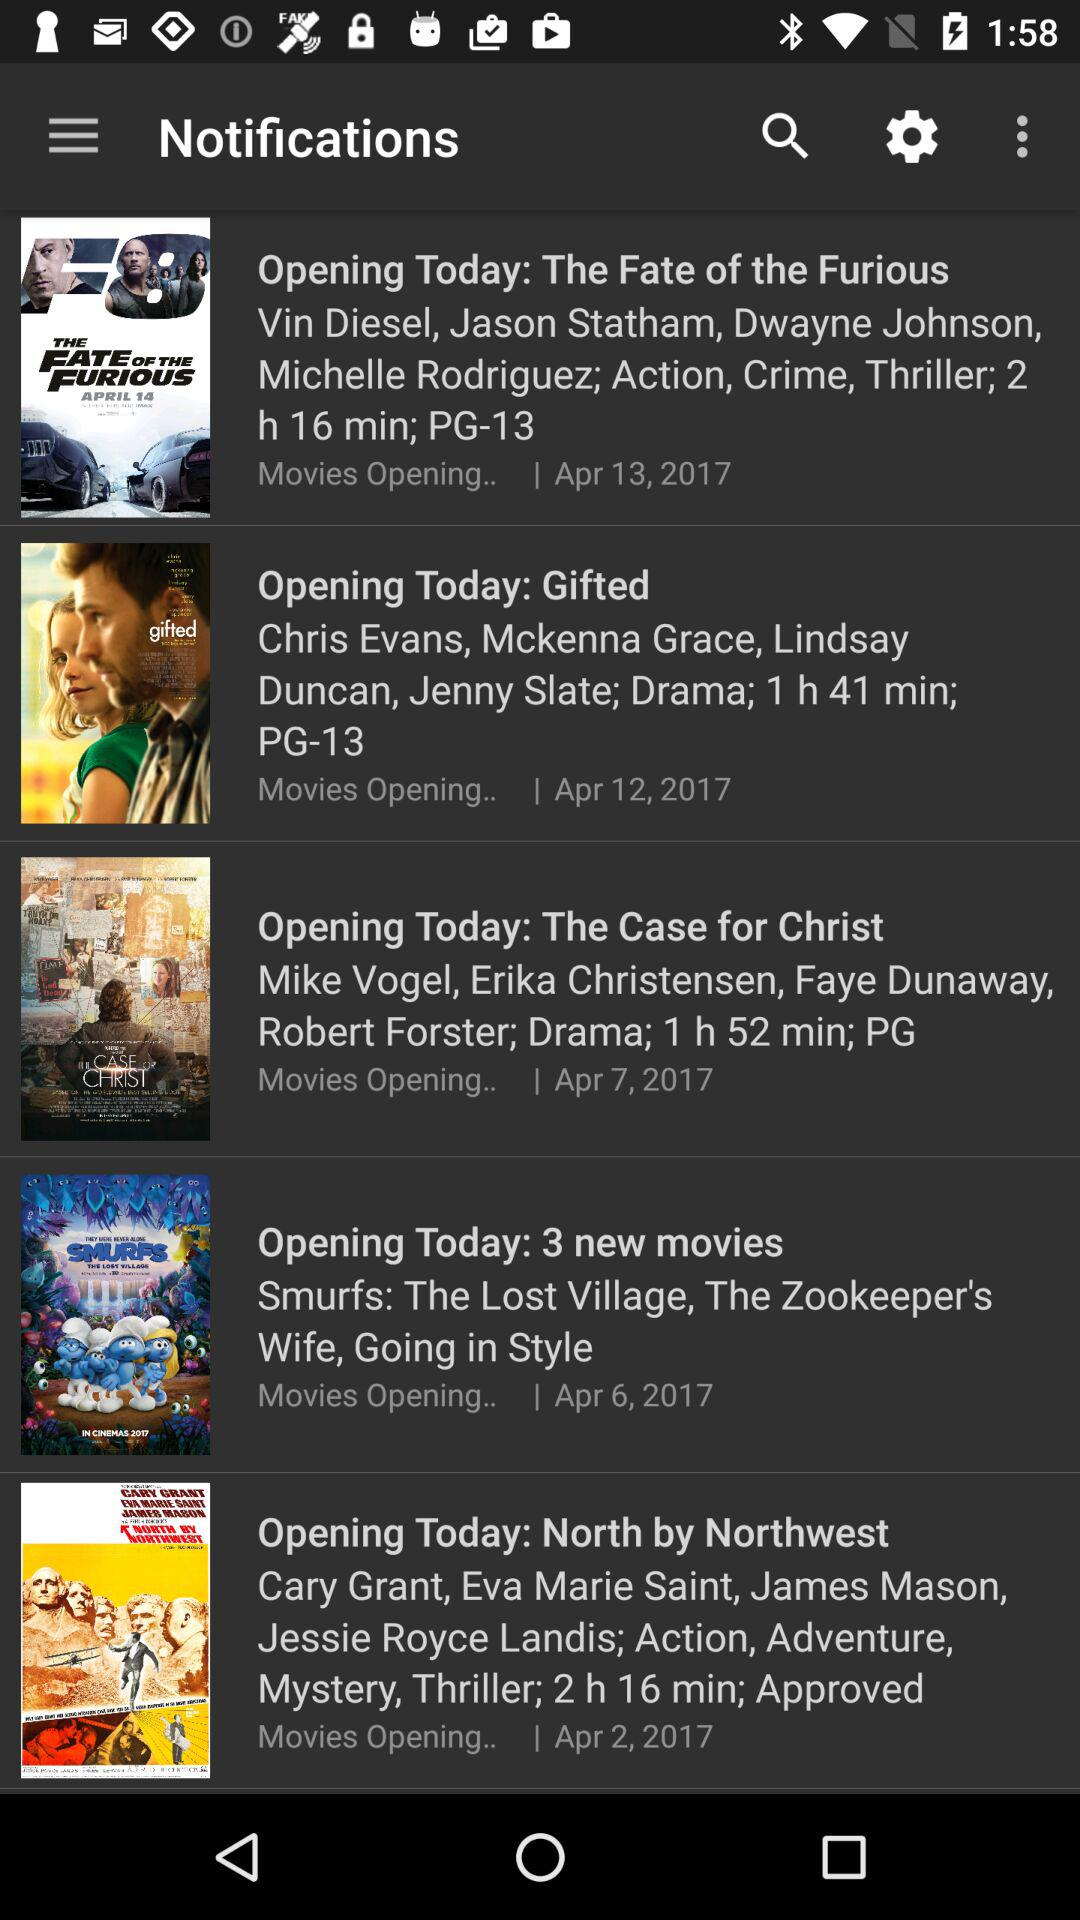How many movies are opening today?
Answer the question using a single word or phrase. 5 